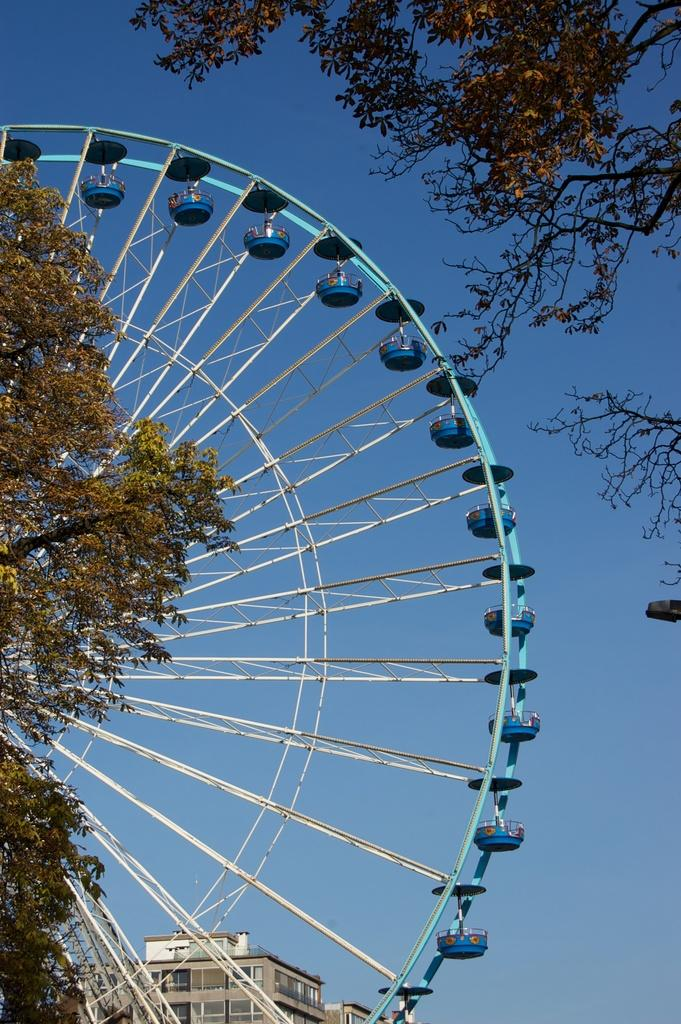What type of vegetation is in the foreground of the picture? There are trees in the foreground of the picture. What is the main object in the center of the picture? There is a ferrous wheel in the center of the picture. What type of structures can be seen in the background of the picture? There are buildings in the background of the picture. What part of the natural environment is visible in the picture? The sky is visible in the picture. What level of experience does the vest have in the picture? There is no vest present in the image, so it is not possible to determine the level of experience. What month is depicted in the picture? The month is not depicted in the picture; there is no indication of a specific time of year. 